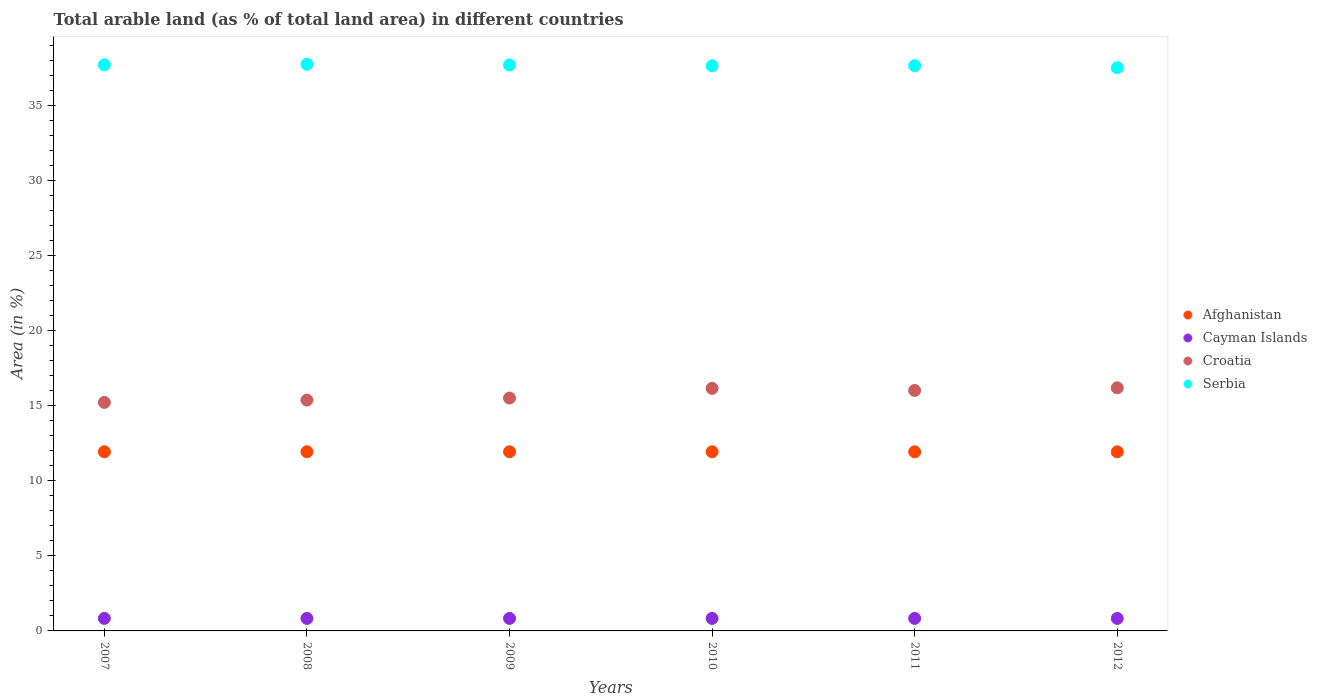Is the number of dotlines equal to the number of legend labels?
Your answer should be very brief. Yes. What is the percentage of arable land in Croatia in 2008?
Give a very brief answer. 15.38. Across all years, what is the maximum percentage of arable land in Croatia?
Provide a short and direct response. 16.2. Across all years, what is the minimum percentage of arable land in Afghanistan?
Your answer should be compact. 11.93. What is the total percentage of arable land in Croatia in the graph?
Ensure brevity in your answer.  94.51. What is the difference between the percentage of arable land in Cayman Islands in 2008 and that in 2010?
Offer a very short reply. 0. What is the difference between the percentage of arable land in Serbia in 2012 and the percentage of arable land in Afghanistan in 2010?
Ensure brevity in your answer.  25.59. What is the average percentage of arable land in Serbia per year?
Make the answer very short. 37.67. In the year 2011, what is the difference between the percentage of arable land in Croatia and percentage of arable land in Cayman Islands?
Offer a terse response. 15.19. What is the ratio of the percentage of arable land in Croatia in 2007 to that in 2009?
Your response must be concise. 0.98. Is the percentage of arable land in Serbia in 2008 less than that in 2011?
Offer a very short reply. No. Is the difference between the percentage of arable land in Croatia in 2008 and 2012 greater than the difference between the percentage of arable land in Cayman Islands in 2008 and 2012?
Provide a succinct answer. No. In how many years, is the percentage of arable land in Croatia greater than the average percentage of arable land in Croatia taken over all years?
Offer a terse response. 3. Is it the case that in every year, the sum of the percentage of arable land in Croatia and percentage of arable land in Cayman Islands  is greater than the sum of percentage of arable land in Serbia and percentage of arable land in Afghanistan?
Your response must be concise. Yes. Is it the case that in every year, the sum of the percentage of arable land in Afghanistan and percentage of arable land in Serbia  is greater than the percentage of arable land in Cayman Islands?
Your response must be concise. Yes. Does the percentage of arable land in Serbia monotonically increase over the years?
Your response must be concise. No. Is the percentage of arable land in Cayman Islands strictly greater than the percentage of arable land in Afghanistan over the years?
Your response must be concise. No. Is the percentage of arable land in Croatia strictly less than the percentage of arable land in Cayman Islands over the years?
Offer a terse response. No. How many years are there in the graph?
Your response must be concise. 6. Are the values on the major ticks of Y-axis written in scientific E-notation?
Provide a succinct answer. No. Does the graph contain any zero values?
Your answer should be compact. No. Does the graph contain grids?
Your answer should be compact. No. Where does the legend appear in the graph?
Make the answer very short. Center right. How many legend labels are there?
Offer a terse response. 4. What is the title of the graph?
Your answer should be compact. Total arable land (as % of total land area) in different countries. What is the label or title of the X-axis?
Your answer should be compact. Years. What is the label or title of the Y-axis?
Your answer should be very brief. Area (in %). What is the Area (in %) of Afghanistan in 2007?
Offer a terse response. 11.94. What is the Area (in %) of Cayman Islands in 2007?
Offer a terse response. 0.83. What is the Area (in %) in Croatia in 2007?
Your response must be concise. 15.23. What is the Area (in %) of Serbia in 2007?
Provide a succinct answer. 37.72. What is the Area (in %) in Afghanistan in 2008?
Your response must be concise. 11.94. What is the Area (in %) of Cayman Islands in 2008?
Ensure brevity in your answer.  0.83. What is the Area (in %) in Croatia in 2008?
Give a very brief answer. 15.38. What is the Area (in %) in Serbia in 2008?
Your response must be concise. 37.75. What is the Area (in %) in Afghanistan in 2009?
Your answer should be compact. 11.94. What is the Area (in %) in Cayman Islands in 2009?
Your response must be concise. 0.83. What is the Area (in %) of Croatia in 2009?
Keep it short and to the point. 15.52. What is the Area (in %) of Serbia in 2009?
Make the answer very short. 37.71. What is the Area (in %) in Afghanistan in 2010?
Provide a short and direct response. 11.94. What is the Area (in %) of Cayman Islands in 2010?
Your answer should be compact. 0.83. What is the Area (in %) in Croatia in 2010?
Make the answer very short. 16.16. What is the Area (in %) of Serbia in 2010?
Keep it short and to the point. 37.65. What is the Area (in %) in Afghanistan in 2011?
Provide a short and direct response. 11.93. What is the Area (in %) of Cayman Islands in 2011?
Provide a short and direct response. 0.83. What is the Area (in %) in Croatia in 2011?
Offer a terse response. 16.02. What is the Area (in %) of Serbia in 2011?
Your answer should be compact. 37.66. What is the Area (in %) in Afghanistan in 2012?
Provide a short and direct response. 11.93. What is the Area (in %) in Cayman Islands in 2012?
Provide a short and direct response. 0.83. What is the Area (in %) in Croatia in 2012?
Offer a terse response. 16.2. What is the Area (in %) in Serbia in 2012?
Keep it short and to the point. 37.53. Across all years, what is the maximum Area (in %) of Afghanistan?
Ensure brevity in your answer.  11.94. Across all years, what is the maximum Area (in %) of Cayman Islands?
Make the answer very short. 0.83. Across all years, what is the maximum Area (in %) of Croatia?
Provide a succinct answer. 16.2. Across all years, what is the maximum Area (in %) of Serbia?
Provide a succinct answer. 37.75. Across all years, what is the minimum Area (in %) in Afghanistan?
Give a very brief answer. 11.93. Across all years, what is the minimum Area (in %) of Cayman Islands?
Ensure brevity in your answer.  0.83. Across all years, what is the minimum Area (in %) of Croatia?
Your answer should be very brief. 15.23. Across all years, what is the minimum Area (in %) in Serbia?
Your answer should be compact. 37.53. What is the total Area (in %) of Afghanistan in the graph?
Your answer should be very brief. 71.62. What is the total Area (in %) of Croatia in the graph?
Make the answer very short. 94.5. What is the total Area (in %) of Serbia in the graph?
Give a very brief answer. 226.02. What is the difference between the Area (in %) of Croatia in 2007 and that in 2008?
Your answer should be compact. -0.16. What is the difference between the Area (in %) in Serbia in 2007 and that in 2008?
Ensure brevity in your answer.  -0.03. What is the difference between the Area (in %) of Afghanistan in 2007 and that in 2009?
Your answer should be compact. 0. What is the difference between the Area (in %) of Croatia in 2007 and that in 2009?
Provide a succinct answer. -0.29. What is the difference between the Area (in %) in Serbia in 2007 and that in 2009?
Give a very brief answer. 0.01. What is the difference between the Area (in %) in Afghanistan in 2007 and that in 2010?
Offer a terse response. 0. What is the difference between the Area (in %) in Croatia in 2007 and that in 2010?
Make the answer very short. -0.94. What is the difference between the Area (in %) in Serbia in 2007 and that in 2010?
Your response must be concise. 0.07. What is the difference between the Area (in %) in Afghanistan in 2007 and that in 2011?
Ensure brevity in your answer.  0. What is the difference between the Area (in %) in Croatia in 2007 and that in 2011?
Offer a terse response. -0.8. What is the difference between the Area (in %) of Serbia in 2007 and that in 2011?
Your answer should be compact. 0.06. What is the difference between the Area (in %) of Afghanistan in 2007 and that in 2012?
Offer a terse response. 0.01. What is the difference between the Area (in %) in Cayman Islands in 2007 and that in 2012?
Your answer should be very brief. 0. What is the difference between the Area (in %) of Croatia in 2007 and that in 2012?
Your answer should be very brief. -0.97. What is the difference between the Area (in %) of Serbia in 2007 and that in 2012?
Offer a very short reply. 0.19. What is the difference between the Area (in %) of Afghanistan in 2008 and that in 2009?
Your response must be concise. 0. What is the difference between the Area (in %) of Croatia in 2008 and that in 2009?
Offer a very short reply. -0.14. What is the difference between the Area (in %) in Serbia in 2008 and that in 2009?
Keep it short and to the point. 0.05. What is the difference between the Area (in %) of Afghanistan in 2008 and that in 2010?
Ensure brevity in your answer.  0. What is the difference between the Area (in %) of Cayman Islands in 2008 and that in 2010?
Provide a succinct answer. 0. What is the difference between the Area (in %) in Croatia in 2008 and that in 2010?
Provide a short and direct response. -0.78. What is the difference between the Area (in %) in Serbia in 2008 and that in 2010?
Offer a terse response. 0.1. What is the difference between the Area (in %) of Afghanistan in 2008 and that in 2011?
Your answer should be compact. 0. What is the difference between the Area (in %) of Croatia in 2008 and that in 2011?
Your answer should be very brief. -0.64. What is the difference between the Area (in %) in Serbia in 2008 and that in 2011?
Your answer should be very brief. 0.09. What is the difference between the Area (in %) in Afghanistan in 2008 and that in 2012?
Ensure brevity in your answer.  0.01. What is the difference between the Area (in %) in Croatia in 2008 and that in 2012?
Give a very brief answer. -0.82. What is the difference between the Area (in %) of Serbia in 2008 and that in 2012?
Give a very brief answer. 0.23. What is the difference between the Area (in %) in Afghanistan in 2009 and that in 2010?
Give a very brief answer. 0. What is the difference between the Area (in %) in Cayman Islands in 2009 and that in 2010?
Make the answer very short. 0. What is the difference between the Area (in %) in Croatia in 2009 and that in 2010?
Provide a short and direct response. -0.65. What is the difference between the Area (in %) in Serbia in 2009 and that in 2010?
Provide a succinct answer. 0.06. What is the difference between the Area (in %) of Afghanistan in 2009 and that in 2011?
Your answer should be very brief. 0. What is the difference between the Area (in %) in Cayman Islands in 2009 and that in 2011?
Offer a very short reply. 0. What is the difference between the Area (in %) of Croatia in 2009 and that in 2011?
Your response must be concise. -0.51. What is the difference between the Area (in %) in Serbia in 2009 and that in 2011?
Your answer should be very brief. 0.05. What is the difference between the Area (in %) in Afghanistan in 2009 and that in 2012?
Give a very brief answer. 0. What is the difference between the Area (in %) of Croatia in 2009 and that in 2012?
Provide a succinct answer. -0.68. What is the difference between the Area (in %) of Serbia in 2009 and that in 2012?
Keep it short and to the point. 0.18. What is the difference between the Area (in %) of Afghanistan in 2010 and that in 2011?
Ensure brevity in your answer.  0. What is the difference between the Area (in %) in Croatia in 2010 and that in 2011?
Offer a terse response. 0.14. What is the difference between the Area (in %) in Serbia in 2010 and that in 2011?
Provide a succinct answer. -0.01. What is the difference between the Area (in %) of Afghanistan in 2010 and that in 2012?
Make the answer very short. 0. What is the difference between the Area (in %) in Cayman Islands in 2010 and that in 2012?
Provide a short and direct response. 0. What is the difference between the Area (in %) in Croatia in 2010 and that in 2012?
Make the answer very short. -0.04. What is the difference between the Area (in %) of Serbia in 2010 and that in 2012?
Your answer should be compact. 0.13. What is the difference between the Area (in %) in Afghanistan in 2011 and that in 2012?
Your response must be concise. 0. What is the difference between the Area (in %) of Croatia in 2011 and that in 2012?
Offer a terse response. -0.17. What is the difference between the Area (in %) in Serbia in 2011 and that in 2012?
Your answer should be compact. 0.14. What is the difference between the Area (in %) of Afghanistan in 2007 and the Area (in %) of Cayman Islands in 2008?
Keep it short and to the point. 11.1. What is the difference between the Area (in %) in Afghanistan in 2007 and the Area (in %) in Croatia in 2008?
Offer a very short reply. -3.44. What is the difference between the Area (in %) of Afghanistan in 2007 and the Area (in %) of Serbia in 2008?
Ensure brevity in your answer.  -25.82. What is the difference between the Area (in %) of Cayman Islands in 2007 and the Area (in %) of Croatia in 2008?
Keep it short and to the point. -14.55. What is the difference between the Area (in %) of Cayman Islands in 2007 and the Area (in %) of Serbia in 2008?
Your answer should be compact. -36.92. What is the difference between the Area (in %) of Croatia in 2007 and the Area (in %) of Serbia in 2008?
Offer a terse response. -22.53. What is the difference between the Area (in %) in Afghanistan in 2007 and the Area (in %) in Cayman Islands in 2009?
Ensure brevity in your answer.  11.1. What is the difference between the Area (in %) of Afghanistan in 2007 and the Area (in %) of Croatia in 2009?
Make the answer very short. -3.58. What is the difference between the Area (in %) in Afghanistan in 2007 and the Area (in %) in Serbia in 2009?
Provide a short and direct response. -25.77. What is the difference between the Area (in %) of Cayman Islands in 2007 and the Area (in %) of Croatia in 2009?
Give a very brief answer. -14.68. What is the difference between the Area (in %) of Cayman Islands in 2007 and the Area (in %) of Serbia in 2009?
Keep it short and to the point. -36.88. What is the difference between the Area (in %) in Croatia in 2007 and the Area (in %) in Serbia in 2009?
Ensure brevity in your answer.  -22.48. What is the difference between the Area (in %) in Afghanistan in 2007 and the Area (in %) in Cayman Islands in 2010?
Offer a terse response. 11.1. What is the difference between the Area (in %) in Afghanistan in 2007 and the Area (in %) in Croatia in 2010?
Your answer should be very brief. -4.22. What is the difference between the Area (in %) in Afghanistan in 2007 and the Area (in %) in Serbia in 2010?
Make the answer very short. -25.71. What is the difference between the Area (in %) of Cayman Islands in 2007 and the Area (in %) of Croatia in 2010?
Your answer should be compact. -15.33. What is the difference between the Area (in %) in Cayman Islands in 2007 and the Area (in %) in Serbia in 2010?
Provide a succinct answer. -36.82. What is the difference between the Area (in %) in Croatia in 2007 and the Area (in %) in Serbia in 2010?
Ensure brevity in your answer.  -22.43. What is the difference between the Area (in %) of Afghanistan in 2007 and the Area (in %) of Cayman Islands in 2011?
Keep it short and to the point. 11.1. What is the difference between the Area (in %) of Afghanistan in 2007 and the Area (in %) of Croatia in 2011?
Make the answer very short. -4.09. What is the difference between the Area (in %) in Afghanistan in 2007 and the Area (in %) in Serbia in 2011?
Offer a terse response. -25.72. What is the difference between the Area (in %) of Cayman Islands in 2007 and the Area (in %) of Croatia in 2011?
Give a very brief answer. -15.19. What is the difference between the Area (in %) in Cayman Islands in 2007 and the Area (in %) in Serbia in 2011?
Provide a short and direct response. -36.83. What is the difference between the Area (in %) of Croatia in 2007 and the Area (in %) of Serbia in 2011?
Provide a short and direct response. -22.44. What is the difference between the Area (in %) in Afghanistan in 2007 and the Area (in %) in Cayman Islands in 2012?
Your answer should be compact. 11.1. What is the difference between the Area (in %) of Afghanistan in 2007 and the Area (in %) of Croatia in 2012?
Make the answer very short. -4.26. What is the difference between the Area (in %) in Afghanistan in 2007 and the Area (in %) in Serbia in 2012?
Offer a very short reply. -25.59. What is the difference between the Area (in %) of Cayman Islands in 2007 and the Area (in %) of Croatia in 2012?
Provide a short and direct response. -15.36. What is the difference between the Area (in %) of Cayman Islands in 2007 and the Area (in %) of Serbia in 2012?
Your response must be concise. -36.69. What is the difference between the Area (in %) in Croatia in 2007 and the Area (in %) in Serbia in 2012?
Your answer should be very brief. -22.3. What is the difference between the Area (in %) of Afghanistan in 2008 and the Area (in %) of Cayman Islands in 2009?
Keep it short and to the point. 11.1. What is the difference between the Area (in %) of Afghanistan in 2008 and the Area (in %) of Croatia in 2009?
Your answer should be compact. -3.58. What is the difference between the Area (in %) in Afghanistan in 2008 and the Area (in %) in Serbia in 2009?
Make the answer very short. -25.77. What is the difference between the Area (in %) in Cayman Islands in 2008 and the Area (in %) in Croatia in 2009?
Your response must be concise. -14.68. What is the difference between the Area (in %) in Cayman Islands in 2008 and the Area (in %) in Serbia in 2009?
Make the answer very short. -36.88. What is the difference between the Area (in %) of Croatia in 2008 and the Area (in %) of Serbia in 2009?
Ensure brevity in your answer.  -22.33. What is the difference between the Area (in %) of Afghanistan in 2008 and the Area (in %) of Cayman Islands in 2010?
Make the answer very short. 11.1. What is the difference between the Area (in %) in Afghanistan in 2008 and the Area (in %) in Croatia in 2010?
Your answer should be very brief. -4.22. What is the difference between the Area (in %) in Afghanistan in 2008 and the Area (in %) in Serbia in 2010?
Your response must be concise. -25.71. What is the difference between the Area (in %) in Cayman Islands in 2008 and the Area (in %) in Croatia in 2010?
Make the answer very short. -15.33. What is the difference between the Area (in %) of Cayman Islands in 2008 and the Area (in %) of Serbia in 2010?
Provide a short and direct response. -36.82. What is the difference between the Area (in %) in Croatia in 2008 and the Area (in %) in Serbia in 2010?
Your answer should be compact. -22.27. What is the difference between the Area (in %) of Afghanistan in 2008 and the Area (in %) of Cayman Islands in 2011?
Give a very brief answer. 11.1. What is the difference between the Area (in %) in Afghanistan in 2008 and the Area (in %) in Croatia in 2011?
Your response must be concise. -4.09. What is the difference between the Area (in %) of Afghanistan in 2008 and the Area (in %) of Serbia in 2011?
Ensure brevity in your answer.  -25.72. What is the difference between the Area (in %) of Cayman Islands in 2008 and the Area (in %) of Croatia in 2011?
Make the answer very short. -15.19. What is the difference between the Area (in %) in Cayman Islands in 2008 and the Area (in %) in Serbia in 2011?
Offer a very short reply. -36.83. What is the difference between the Area (in %) in Croatia in 2008 and the Area (in %) in Serbia in 2011?
Provide a short and direct response. -22.28. What is the difference between the Area (in %) in Afghanistan in 2008 and the Area (in %) in Cayman Islands in 2012?
Ensure brevity in your answer.  11.1. What is the difference between the Area (in %) of Afghanistan in 2008 and the Area (in %) of Croatia in 2012?
Your response must be concise. -4.26. What is the difference between the Area (in %) in Afghanistan in 2008 and the Area (in %) in Serbia in 2012?
Keep it short and to the point. -25.59. What is the difference between the Area (in %) of Cayman Islands in 2008 and the Area (in %) of Croatia in 2012?
Your answer should be compact. -15.36. What is the difference between the Area (in %) in Cayman Islands in 2008 and the Area (in %) in Serbia in 2012?
Provide a short and direct response. -36.69. What is the difference between the Area (in %) of Croatia in 2008 and the Area (in %) of Serbia in 2012?
Provide a succinct answer. -22.15. What is the difference between the Area (in %) of Afghanistan in 2009 and the Area (in %) of Cayman Islands in 2010?
Provide a succinct answer. 11.1. What is the difference between the Area (in %) of Afghanistan in 2009 and the Area (in %) of Croatia in 2010?
Your response must be concise. -4.22. What is the difference between the Area (in %) in Afghanistan in 2009 and the Area (in %) in Serbia in 2010?
Give a very brief answer. -25.71. What is the difference between the Area (in %) in Cayman Islands in 2009 and the Area (in %) in Croatia in 2010?
Provide a short and direct response. -15.33. What is the difference between the Area (in %) in Cayman Islands in 2009 and the Area (in %) in Serbia in 2010?
Keep it short and to the point. -36.82. What is the difference between the Area (in %) of Croatia in 2009 and the Area (in %) of Serbia in 2010?
Your answer should be compact. -22.14. What is the difference between the Area (in %) of Afghanistan in 2009 and the Area (in %) of Cayman Islands in 2011?
Ensure brevity in your answer.  11.1. What is the difference between the Area (in %) of Afghanistan in 2009 and the Area (in %) of Croatia in 2011?
Offer a terse response. -4.09. What is the difference between the Area (in %) of Afghanistan in 2009 and the Area (in %) of Serbia in 2011?
Provide a short and direct response. -25.73. What is the difference between the Area (in %) of Cayman Islands in 2009 and the Area (in %) of Croatia in 2011?
Ensure brevity in your answer.  -15.19. What is the difference between the Area (in %) of Cayman Islands in 2009 and the Area (in %) of Serbia in 2011?
Make the answer very short. -36.83. What is the difference between the Area (in %) in Croatia in 2009 and the Area (in %) in Serbia in 2011?
Offer a terse response. -22.15. What is the difference between the Area (in %) in Afghanistan in 2009 and the Area (in %) in Cayman Islands in 2012?
Provide a short and direct response. 11.1. What is the difference between the Area (in %) of Afghanistan in 2009 and the Area (in %) of Croatia in 2012?
Your answer should be very brief. -4.26. What is the difference between the Area (in %) of Afghanistan in 2009 and the Area (in %) of Serbia in 2012?
Provide a short and direct response. -25.59. What is the difference between the Area (in %) of Cayman Islands in 2009 and the Area (in %) of Croatia in 2012?
Your response must be concise. -15.36. What is the difference between the Area (in %) in Cayman Islands in 2009 and the Area (in %) in Serbia in 2012?
Keep it short and to the point. -36.69. What is the difference between the Area (in %) in Croatia in 2009 and the Area (in %) in Serbia in 2012?
Offer a very short reply. -22.01. What is the difference between the Area (in %) of Afghanistan in 2010 and the Area (in %) of Cayman Islands in 2011?
Offer a very short reply. 11.1. What is the difference between the Area (in %) in Afghanistan in 2010 and the Area (in %) in Croatia in 2011?
Offer a terse response. -4.09. What is the difference between the Area (in %) of Afghanistan in 2010 and the Area (in %) of Serbia in 2011?
Ensure brevity in your answer.  -25.73. What is the difference between the Area (in %) of Cayman Islands in 2010 and the Area (in %) of Croatia in 2011?
Offer a terse response. -15.19. What is the difference between the Area (in %) in Cayman Islands in 2010 and the Area (in %) in Serbia in 2011?
Provide a succinct answer. -36.83. What is the difference between the Area (in %) in Croatia in 2010 and the Area (in %) in Serbia in 2011?
Offer a terse response. -21.5. What is the difference between the Area (in %) in Afghanistan in 2010 and the Area (in %) in Cayman Islands in 2012?
Your answer should be compact. 11.1. What is the difference between the Area (in %) in Afghanistan in 2010 and the Area (in %) in Croatia in 2012?
Give a very brief answer. -4.26. What is the difference between the Area (in %) of Afghanistan in 2010 and the Area (in %) of Serbia in 2012?
Provide a short and direct response. -25.59. What is the difference between the Area (in %) of Cayman Islands in 2010 and the Area (in %) of Croatia in 2012?
Provide a succinct answer. -15.36. What is the difference between the Area (in %) in Cayman Islands in 2010 and the Area (in %) in Serbia in 2012?
Offer a very short reply. -36.69. What is the difference between the Area (in %) of Croatia in 2010 and the Area (in %) of Serbia in 2012?
Your answer should be very brief. -21.36. What is the difference between the Area (in %) of Afghanistan in 2011 and the Area (in %) of Cayman Islands in 2012?
Ensure brevity in your answer.  11.1. What is the difference between the Area (in %) of Afghanistan in 2011 and the Area (in %) of Croatia in 2012?
Your response must be concise. -4.26. What is the difference between the Area (in %) of Afghanistan in 2011 and the Area (in %) of Serbia in 2012?
Keep it short and to the point. -25.59. What is the difference between the Area (in %) of Cayman Islands in 2011 and the Area (in %) of Croatia in 2012?
Offer a terse response. -15.36. What is the difference between the Area (in %) of Cayman Islands in 2011 and the Area (in %) of Serbia in 2012?
Provide a succinct answer. -36.69. What is the difference between the Area (in %) in Croatia in 2011 and the Area (in %) in Serbia in 2012?
Provide a succinct answer. -21.5. What is the average Area (in %) of Afghanistan per year?
Give a very brief answer. 11.94. What is the average Area (in %) of Croatia per year?
Keep it short and to the point. 15.75. What is the average Area (in %) in Serbia per year?
Your response must be concise. 37.67. In the year 2007, what is the difference between the Area (in %) of Afghanistan and Area (in %) of Cayman Islands?
Offer a terse response. 11.1. In the year 2007, what is the difference between the Area (in %) of Afghanistan and Area (in %) of Croatia?
Offer a terse response. -3.29. In the year 2007, what is the difference between the Area (in %) in Afghanistan and Area (in %) in Serbia?
Offer a very short reply. -25.78. In the year 2007, what is the difference between the Area (in %) in Cayman Islands and Area (in %) in Croatia?
Give a very brief answer. -14.39. In the year 2007, what is the difference between the Area (in %) of Cayman Islands and Area (in %) of Serbia?
Provide a short and direct response. -36.89. In the year 2007, what is the difference between the Area (in %) in Croatia and Area (in %) in Serbia?
Your answer should be compact. -22.49. In the year 2008, what is the difference between the Area (in %) in Afghanistan and Area (in %) in Cayman Islands?
Make the answer very short. 11.1. In the year 2008, what is the difference between the Area (in %) in Afghanistan and Area (in %) in Croatia?
Your answer should be very brief. -3.44. In the year 2008, what is the difference between the Area (in %) in Afghanistan and Area (in %) in Serbia?
Your answer should be compact. -25.82. In the year 2008, what is the difference between the Area (in %) of Cayman Islands and Area (in %) of Croatia?
Your response must be concise. -14.55. In the year 2008, what is the difference between the Area (in %) of Cayman Islands and Area (in %) of Serbia?
Ensure brevity in your answer.  -36.92. In the year 2008, what is the difference between the Area (in %) in Croatia and Area (in %) in Serbia?
Give a very brief answer. -22.37. In the year 2009, what is the difference between the Area (in %) of Afghanistan and Area (in %) of Cayman Islands?
Keep it short and to the point. 11.1. In the year 2009, what is the difference between the Area (in %) of Afghanistan and Area (in %) of Croatia?
Your response must be concise. -3.58. In the year 2009, what is the difference between the Area (in %) in Afghanistan and Area (in %) in Serbia?
Your answer should be compact. -25.77. In the year 2009, what is the difference between the Area (in %) in Cayman Islands and Area (in %) in Croatia?
Provide a short and direct response. -14.68. In the year 2009, what is the difference between the Area (in %) of Cayman Islands and Area (in %) of Serbia?
Your answer should be compact. -36.88. In the year 2009, what is the difference between the Area (in %) of Croatia and Area (in %) of Serbia?
Your response must be concise. -22.19. In the year 2010, what is the difference between the Area (in %) in Afghanistan and Area (in %) in Cayman Islands?
Offer a very short reply. 11.1. In the year 2010, what is the difference between the Area (in %) of Afghanistan and Area (in %) of Croatia?
Your answer should be very brief. -4.22. In the year 2010, what is the difference between the Area (in %) in Afghanistan and Area (in %) in Serbia?
Your answer should be very brief. -25.71. In the year 2010, what is the difference between the Area (in %) of Cayman Islands and Area (in %) of Croatia?
Your answer should be very brief. -15.33. In the year 2010, what is the difference between the Area (in %) of Cayman Islands and Area (in %) of Serbia?
Ensure brevity in your answer.  -36.82. In the year 2010, what is the difference between the Area (in %) of Croatia and Area (in %) of Serbia?
Your answer should be compact. -21.49. In the year 2011, what is the difference between the Area (in %) of Afghanistan and Area (in %) of Cayman Islands?
Your response must be concise. 11.1. In the year 2011, what is the difference between the Area (in %) in Afghanistan and Area (in %) in Croatia?
Give a very brief answer. -4.09. In the year 2011, what is the difference between the Area (in %) of Afghanistan and Area (in %) of Serbia?
Offer a terse response. -25.73. In the year 2011, what is the difference between the Area (in %) in Cayman Islands and Area (in %) in Croatia?
Ensure brevity in your answer.  -15.19. In the year 2011, what is the difference between the Area (in %) of Cayman Islands and Area (in %) of Serbia?
Keep it short and to the point. -36.83. In the year 2011, what is the difference between the Area (in %) of Croatia and Area (in %) of Serbia?
Make the answer very short. -21.64. In the year 2012, what is the difference between the Area (in %) in Afghanistan and Area (in %) in Cayman Islands?
Provide a short and direct response. 11.1. In the year 2012, what is the difference between the Area (in %) of Afghanistan and Area (in %) of Croatia?
Provide a short and direct response. -4.27. In the year 2012, what is the difference between the Area (in %) in Afghanistan and Area (in %) in Serbia?
Offer a terse response. -25.59. In the year 2012, what is the difference between the Area (in %) in Cayman Islands and Area (in %) in Croatia?
Your response must be concise. -15.36. In the year 2012, what is the difference between the Area (in %) in Cayman Islands and Area (in %) in Serbia?
Make the answer very short. -36.69. In the year 2012, what is the difference between the Area (in %) in Croatia and Area (in %) in Serbia?
Ensure brevity in your answer.  -21.33. What is the ratio of the Area (in %) in Afghanistan in 2007 to that in 2008?
Offer a terse response. 1. What is the ratio of the Area (in %) of Cayman Islands in 2007 to that in 2008?
Give a very brief answer. 1. What is the ratio of the Area (in %) of Afghanistan in 2007 to that in 2009?
Provide a short and direct response. 1. What is the ratio of the Area (in %) in Cayman Islands in 2007 to that in 2009?
Provide a short and direct response. 1. What is the ratio of the Area (in %) of Croatia in 2007 to that in 2009?
Offer a terse response. 0.98. What is the ratio of the Area (in %) of Serbia in 2007 to that in 2009?
Make the answer very short. 1. What is the ratio of the Area (in %) of Afghanistan in 2007 to that in 2010?
Your response must be concise. 1. What is the ratio of the Area (in %) of Cayman Islands in 2007 to that in 2010?
Your response must be concise. 1. What is the ratio of the Area (in %) of Croatia in 2007 to that in 2010?
Your response must be concise. 0.94. What is the ratio of the Area (in %) of Cayman Islands in 2007 to that in 2011?
Your answer should be compact. 1. What is the ratio of the Area (in %) of Croatia in 2007 to that in 2011?
Provide a succinct answer. 0.95. What is the ratio of the Area (in %) in Afghanistan in 2007 to that in 2012?
Your answer should be compact. 1. What is the ratio of the Area (in %) in Cayman Islands in 2007 to that in 2012?
Provide a succinct answer. 1. What is the ratio of the Area (in %) of Afghanistan in 2008 to that in 2009?
Provide a succinct answer. 1. What is the ratio of the Area (in %) in Cayman Islands in 2008 to that in 2009?
Offer a terse response. 1. What is the ratio of the Area (in %) in Croatia in 2008 to that in 2009?
Ensure brevity in your answer.  0.99. What is the ratio of the Area (in %) in Serbia in 2008 to that in 2009?
Provide a short and direct response. 1. What is the ratio of the Area (in %) of Afghanistan in 2008 to that in 2010?
Ensure brevity in your answer.  1. What is the ratio of the Area (in %) of Croatia in 2008 to that in 2010?
Keep it short and to the point. 0.95. What is the ratio of the Area (in %) of Serbia in 2008 to that in 2010?
Provide a short and direct response. 1. What is the ratio of the Area (in %) of Afghanistan in 2008 to that in 2011?
Your response must be concise. 1. What is the ratio of the Area (in %) of Croatia in 2008 to that in 2011?
Offer a very short reply. 0.96. What is the ratio of the Area (in %) of Afghanistan in 2008 to that in 2012?
Make the answer very short. 1. What is the ratio of the Area (in %) in Cayman Islands in 2008 to that in 2012?
Keep it short and to the point. 1. What is the ratio of the Area (in %) of Croatia in 2008 to that in 2012?
Offer a very short reply. 0.95. What is the ratio of the Area (in %) in Serbia in 2008 to that in 2012?
Ensure brevity in your answer.  1.01. What is the ratio of the Area (in %) of Croatia in 2009 to that in 2010?
Provide a short and direct response. 0.96. What is the ratio of the Area (in %) of Croatia in 2009 to that in 2011?
Make the answer very short. 0.97. What is the ratio of the Area (in %) in Croatia in 2009 to that in 2012?
Make the answer very short. 0.96. What is the ratio of the Area (in %) of Serbia in 2009 to that in 2012?
Keep it short and to the point. 1. What is the ratio of the Area (in %) in Afghanistan in 2010 to that in 2011?
Make the answer very short. 1. What is the ratio of the Area (in %) in Cayman Islands in 2010 to that in 2011?
Your answer should be compact. 1. What is the ratio of the Area (in %) in Croatia in 2010 to that in 2011?
Ensure brevity in your answer.  1.01. What is the ratio of the Area (in %) in Serbia in 2010 to that in 2011?
Ensure brevity in your answer.  1. What is the ratio of the Area (in %) of Afghanistan in 2010 to that in 2012?
Your answer should be compact. 1. What is the ratio of the Area (in %) of Afghanistan in 2011 to that in 2012?
Keep it short and to the point. 1. What is the ratio of the Area (in %) in Croatia in 2011 to that in 2012?
Offer a very short reply. 0.99. What is the difference between the highest and the second highest Area (in %) in Afghanistan?
Give a very brief answer. 0. What is the difference between the highest and the second highest Area (in %) in Cayman Islands?
Offer a very short reply. 0. What is the difference between the highest and the second highest Area (in %) in Croatia?
Give a very brief answer. 0.04. What is the difference between the highest and the second highest Area (in %) of Serbia?
Ensure brevity in your answer.  0.03. What is the difference between the highest and the lowest Area (in %) of Afghanistan?
Provide a short and direct response. 0.01. What is the difference between the highest and the lowest Area (in %) of Croatia?
Your answer should be very brief. 0.97. What is the difference between the highest and the lowest Area (in %) of Serbia?
Provide a succinct answer. 0.23. 